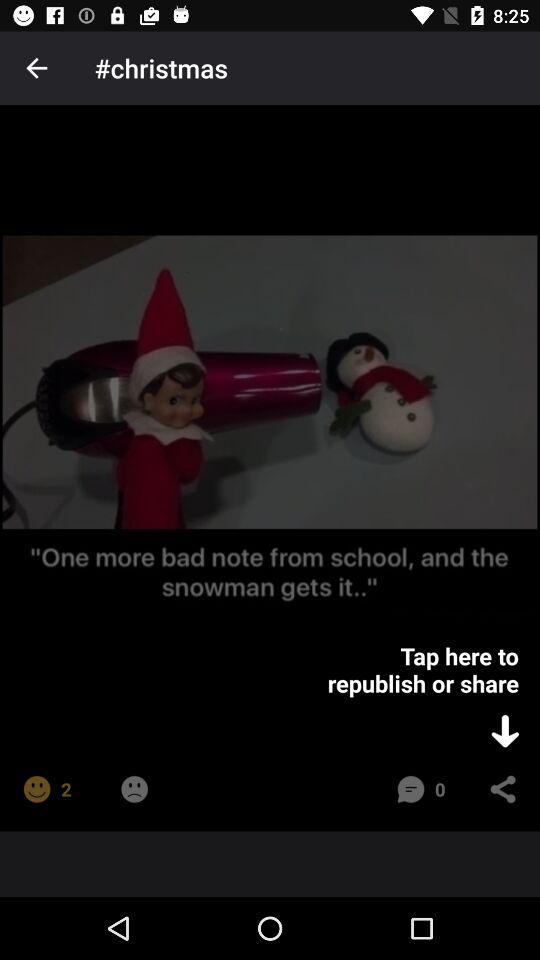What's the total number of comments? The total number of comments is 0. 